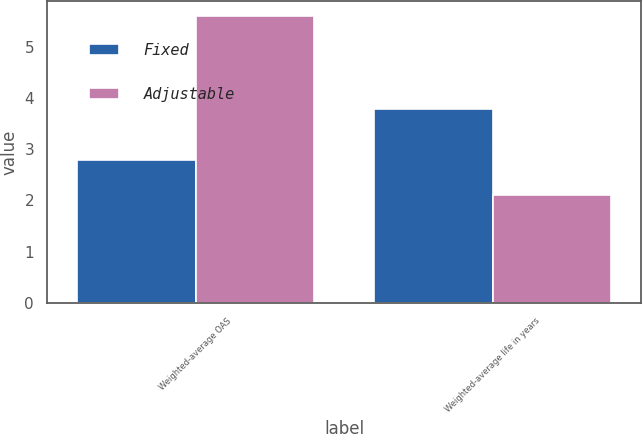Convert chart to OTSL. <chart><loc_0><loc_0><loc_500><loc_500><stacked_bar_chart><ecel><fcel>Weighted-average OAS<fcel>Weighted-average life in years<nl><fcel>Fixed<fcel>2.8<fcel>3.78<nl><fcel>Adjustable<fcel>5.61<fcel>2.1<nl></chart> 